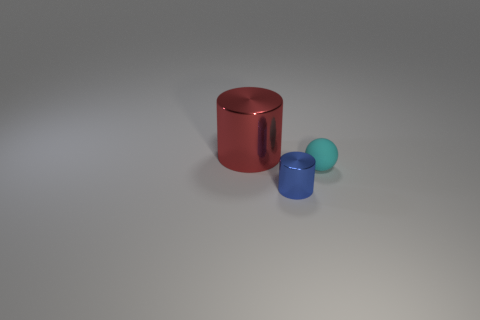Is there anything else that has the same material as the cyan thing?
Your answer should be compact. No. Is the sphere made of the same material as the blue thing?
Keep it short and to the point. No. The shiny cylinder that is the same size as the matte ball is what color?
Offer a terse response. Blue. What number of other objects are there of the same shape as the big red metal object?
Provide a succinct answer. 1. There is a red thing; does it have the same size as the shiny thing that is in front of the red cylinder?
Keep it short and to the point. No. What number of things are large cyan metal spheres or cyan matte spheres?
Your answer should be very brief. 1. How many other objects are the same size as the blue cylinder?
Your answer should be compact. 1. How many blocks are tiny cyan matte objects or red objects?
Offer a terse response. 0. Is there any other thing of the same color as the tiny ball?
Provide a short and direct response. No. What is the material of the object to the left of the metallic thing in front of the red cylinder?
Your response must be concise. Metal. 